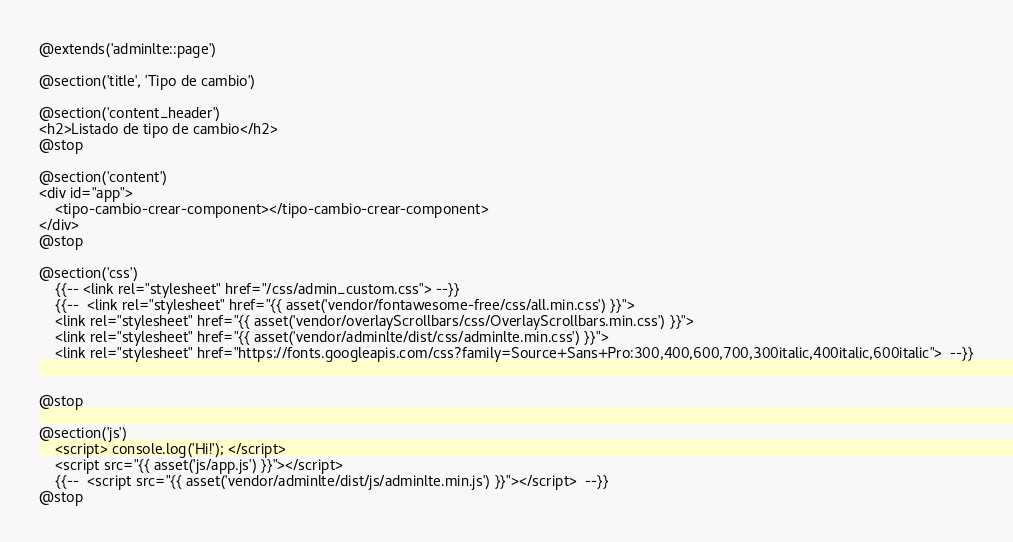<code> <loc_0><loc_0><loc_500><loc_500><_PHP_>@extends('adminlte::page')

@section('title', 'Tipo de cambio')

@section('content_header')
<h2>Listado de tipo de cambio</h2>
@stop

@section('content')
<div id="app">
    <tipo-cambio-crear-component></tipo-cambio-crear-component>
</div>
@stop

@section('css')
    {{-- <link rel="stylesheet" href="/css/admin_custom.css"> --}}
    {{--  <link rel="stylesheet" href="{{ asset('vendor/fontawesome-free/css/all.min.css') }}">
    <link rel="stylesheet" href="{{ asset('vendor/overlayScrollbars/css/OverlayScrollbars.min.css') }}">
    <link rel="stylesheet" href="{{ asset('vendor/adminlte/dist/css/adminlte.min.css') }}">
    <link rel="stylesheet" href="https://fonts.googleapis.com/css?family=Source+Sans+Pro:300,400,600,700,300italic,400italic,600italic">  --}}


@stop

@section('js')
    <script> console.log('Hi!'); </script>
    <script src="{{ asset('js/app.js') }}"></script>
    {{--  <script src="{{ asset('vendor/adminlte/dist/js/adminlte.min.js') }}"></script>  --}}
@stop
</code> 